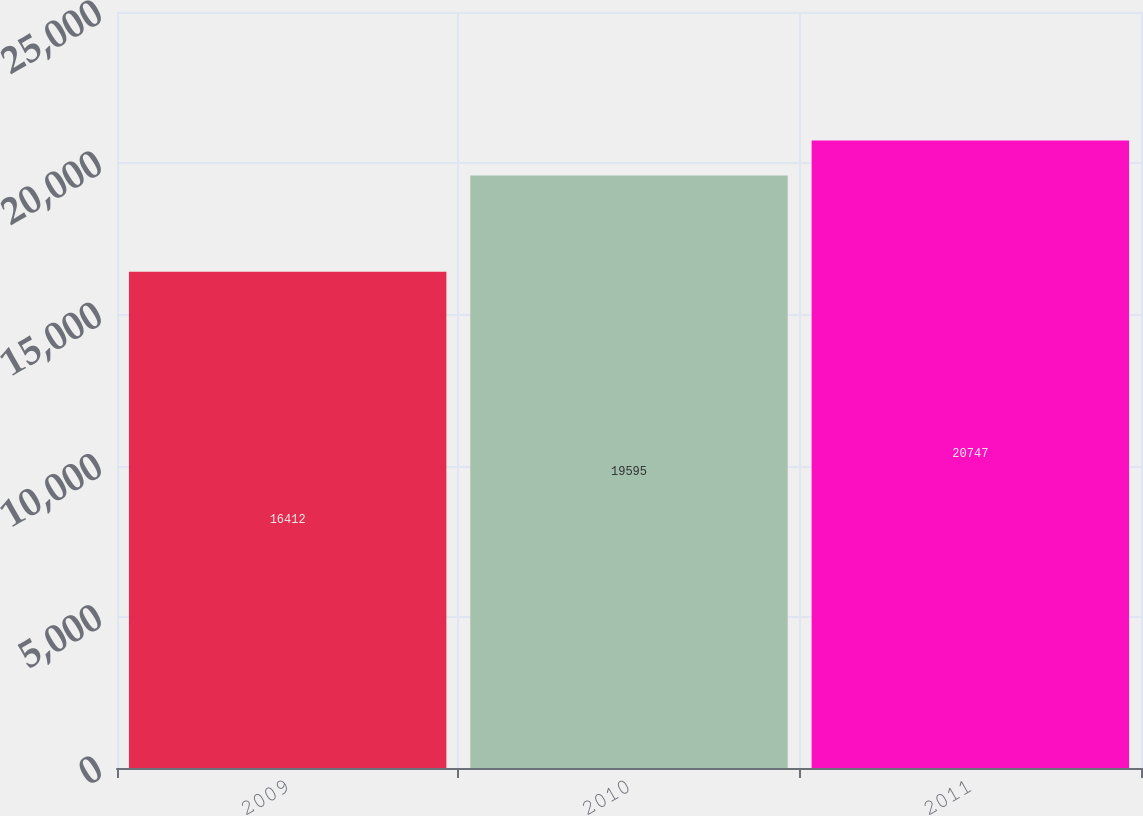Convert chart. <chart><loc_0><loc_0><loc_500><loc_500><bar_chart><fcel>2009<fcel>2010<fcel>2011<nl><fcel>16412<fcel>19595<fcel>20747<nl></chart> 